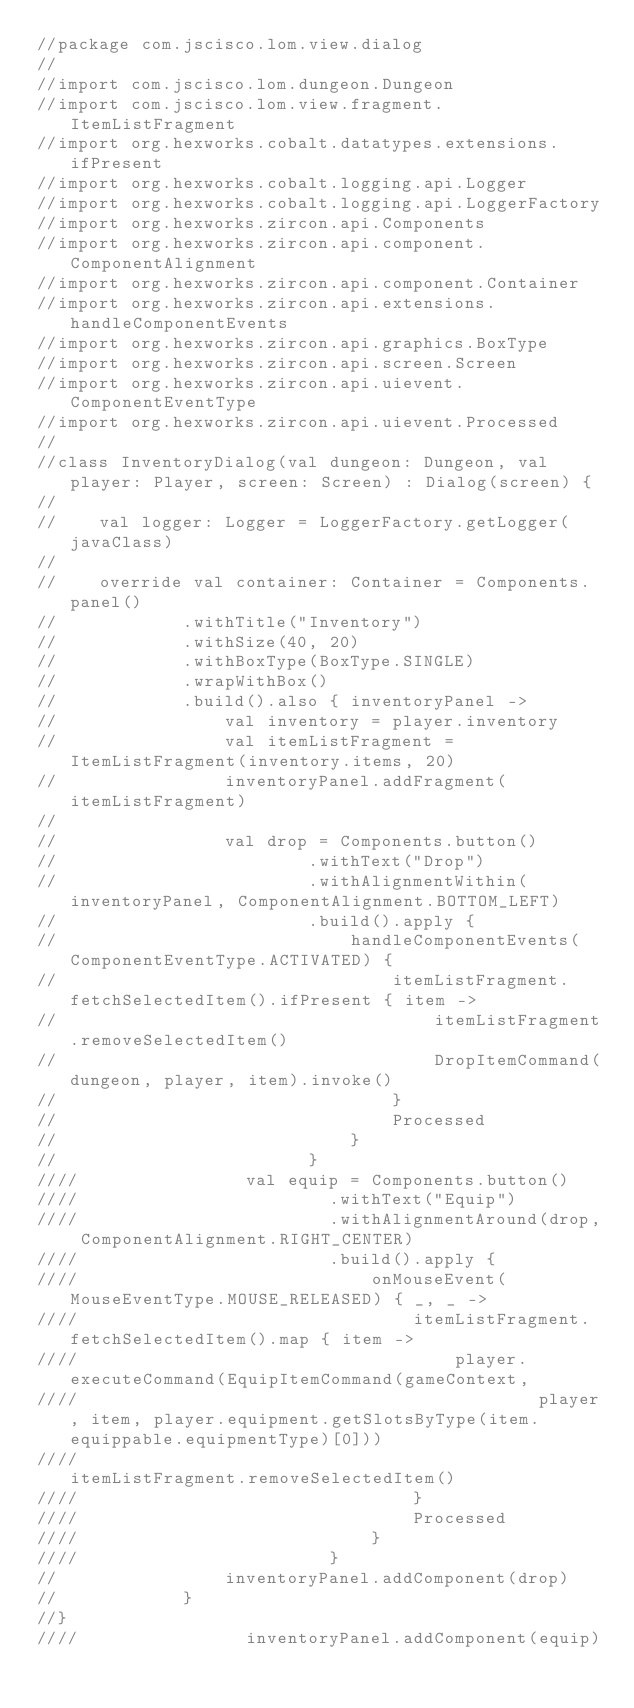Convert code to text. <code><loc_0><loc_0><loc_500><loc_500><_Kotlin_>//package com.jscisco.lom.view.dialog
//
//import com.jscisco.lom.dungeon.Dungeon
//import com.jscisco.lom.view.fragment.ItemListFragment
//import org.hexworks.cobalt.datatypes.extensions.ifPresent
//import org.hexworks.cobalt.logging.api.Logger
//import org.hexworks.cobalt.logging.api.LoggerFactory
//import org.hexworks.zircon.api.Components
//import org.hexworks.zircon.api.component.ComponentAlignment
//import org.hexworks.zircon.api.component.Container
//import org.hexworks.zircon.api.extensions.handleComponentEvents
//import org.hexworks.zircon.api.graphics.BoxType
//import org.hexworks.zircon.api.screen.Screen
//import org.hexworks.zircon.api.uievent.ComponentEventType
//import org.hexworks.zircon.api.uievent.Processed
//
//class InventoryDialog(val dungeon: Dungeon, val player: Player, screen: Screen) : Dialog(screen) {
//
//    val logger: Logger = LoggerFactory.getLogger(javaClass)
//
//    override val container: Container = Components.panel()
//            .withTitle("Inventory")
//            .withSize(40, 20)
//            .withBoxType(BoxType.SINGLE)
//            .wrapWithBox()
//            .build().also { inventoryPanel ->
//                val inventory = player.inventory
//                val itemListFragment = ItemListFragment(inventory.items, 20)
//                inventoryPanel.addFragment(itemListFragment)
//
//                val drop = Components.button()
//                        .withText("Drop")
//                        .withAlignmentWithin(inventoryPanel, ComponentAlignment.BOTTOM_LEFT)
//                        .build().apply {
//                            handleComponentEvents(ComponentEventType.ACTIVATED) {
//                                itemListFragment.fetchSelectedItem().ifPresent { item ->
//                                    itemListFragment.removeSelectedItem()
//                                    DropItemCommand(dungeon, player, item).invoke()
//                                }
//                                Processed
//                            }
//                        }
////                val equip = Components.button()
////                        .withText("Equip")
////                        .withAlignmentAround(drop, ComponentAlignment.RIGHT_CENTER)
////                        .build().apply {
////                            onMouseEvent(MouseEventType.MOUSE_RELEASED) { _, _ ->
////                                itemListFragment.fetchSelectedItem().map { item ->
////                                    player.executeCommand(EquipItemCommand(gameContext,
////                                            player, item, player.equipment.getSlotsByType(item.equippable.equipmentType)[0]))
////                                    itemListFragment.removeSelectedItem()
////                                }
////                                Processed
////                            }
////                        }
//                inventoryPanel.addComponent(drop)
//            }
//}
////                inventoryPanel.addComponent(equip)</code> 